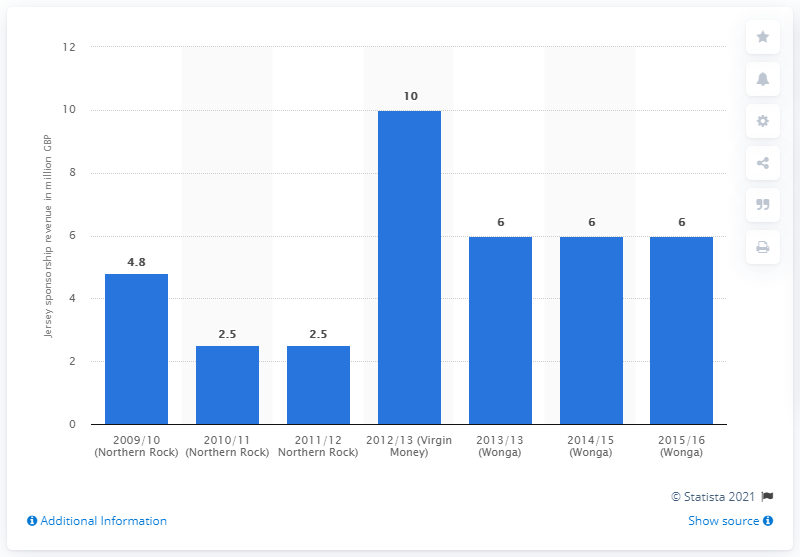Point out several critical features in this image. In the 2012/13 season, Newcastle United received £2.5 million from Virgin Money as part of their sponsorship agreement. 